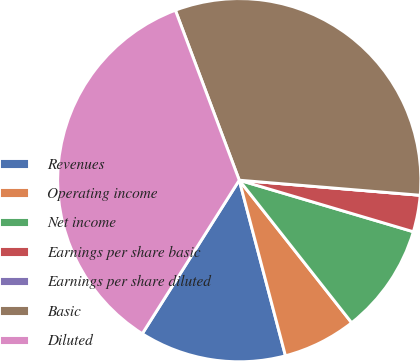Convert chart to OTSL. <chart><loc_0><loc_0><loc_500><loc_500><pie_chart><fcel>Revenues<fcel>Operating income<fcel>Net income<fcel>Earnings per share basic<fcel>Earnings per share diluted<fcel>Basic<fcel>Diluted<nl><fcel>13.06%<fcel>6.53%<fcel>9.79%<fcel>3.26%<fcel>0.0%<fcel>32.04%<fcel>35.31%<nl></chart> 